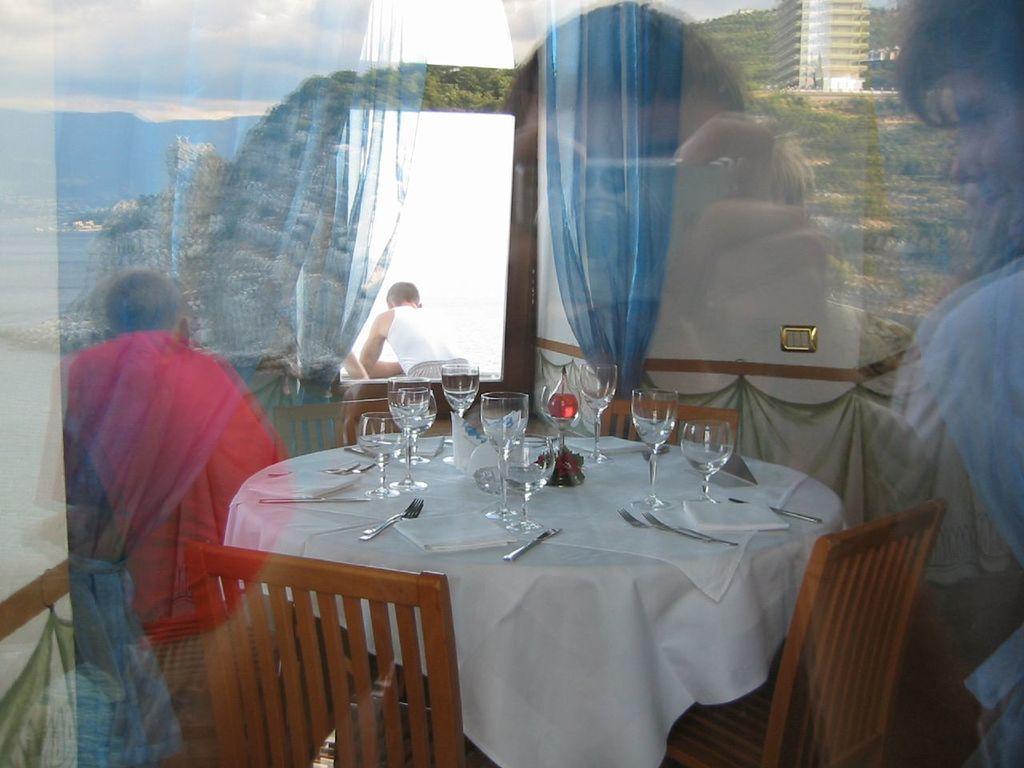In one or two sentences, can you explain what this image depicts? Its a reflection of glass where we can see a table on which we have glasses,spoons,tissue papers,and a curtain,and we also have chairs and a man. There is water in the glass. In the background their is a wall and a curtain and a man is taking a picture of a room with his camera 